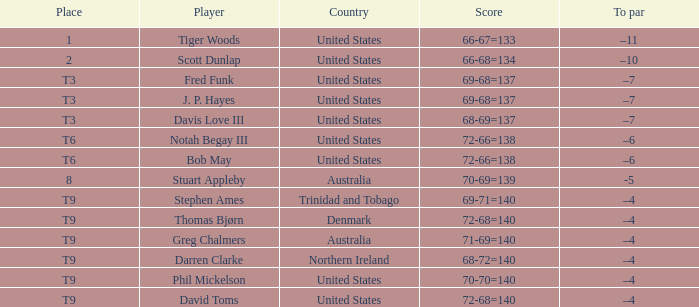What place had a To par of –10? 2.0. 